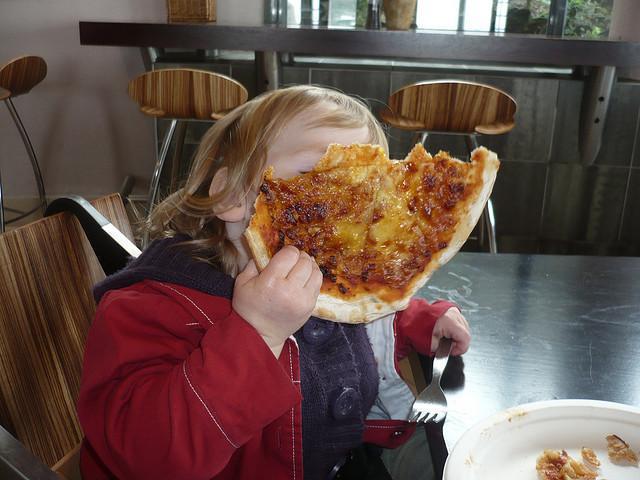How many chairs are visible?
Give a very brief answer. 4. How many dining tables are in the photo?
Give a very brief answer. 2. 